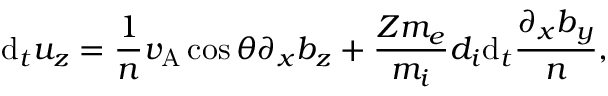Convert formula to latex. <formula><loc_0><loc_0><loc_500><loc_500>d _ { t } u _ { z } = \frac { 1 } { n } v _ { A } \cos \theta \partial _ { x } b _ { z } + \frac { Z m _ { e } } { m _ { i } } d _ { i } d _ { t } \frac { \partial _ { x } b _ { y } } { n } ,</formula> 